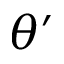Convert formula to latex. <formula><loc_0><loc_0><loc_500><loc_500>\theta ^ { \prime }</formula> 